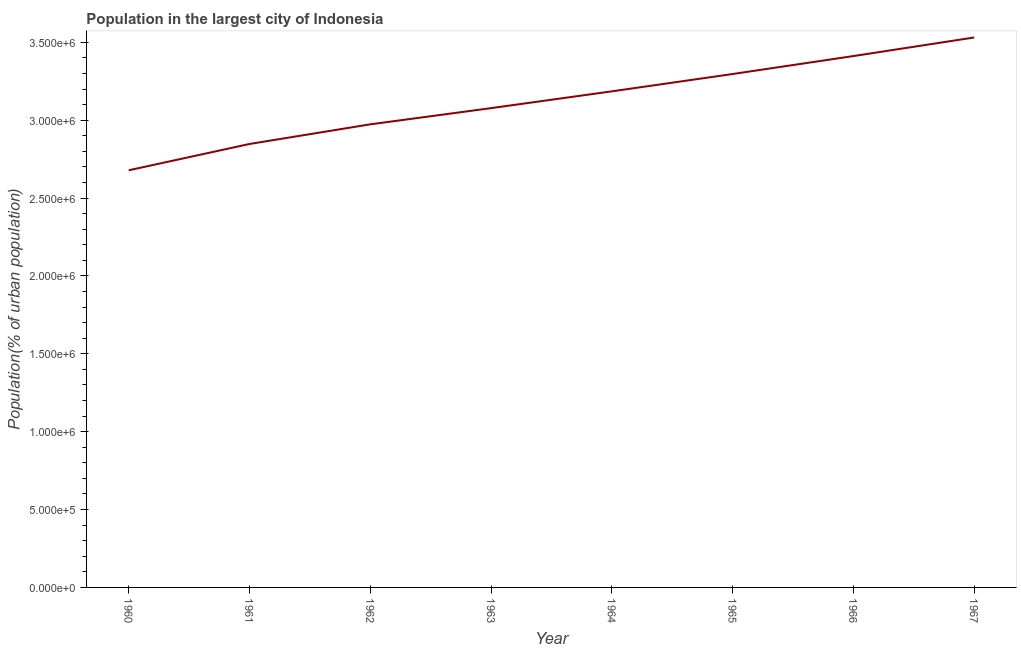What is the population in largest city in 1966?
Ensure brevity in your answer.  3.41e+06. Across all years, what is the maximum population in largest city?
Make the answer very short. 3.53e+06. Across all years, what is the minimum population in largest city?
Make the answer very short. 2.68e+06. In which year was the population in largest city maximum?
Your answer should be very brief. 1967. What is the sum of the population in largest city?
Your response must be concise. 2.50e+07. What is the difference between the population in largest city in 1960 and 1966?
Keep it short and to the point. -7.34e+05. What is the average population in largest city per year?
Your answer should be very brief. 3.13e+06. What is the median population in largest city?
Provide a short and direct response. 3.13e+06. In how many years, is the population in largest city greater than 2100000 %?
Your response must be concise. 8. Do a majority of the years between 1966 and 1960 (inclusive) have population in largest city greater than 500000 %?
Keep it short and to the point. Yes. What is the ratio of the population in largest city in 1965 to that in 1966?
Your answer should be very brief. 0.97. Is the population in largest city in 1963 less than that in 1964?
Your response must be concise. Yes. Is the difference between the population in largest city in 1962 and 1967 greater than the difference between any two years?
Your response must be concise. No. What is the difference between the highest and the second highest population in largest city?
Keep it short and to the point. 1.19e+05. What is the difference between the highest and the lowest population in largest city?
Provide a short and direct response. 8.53e+05. Does the population in largest city monotonically increase over the years?
Make the answer very short. Yes. How many years are there in the graph?
Offer a very short reply. 8. Does the graph contain grids?
Offer a very short reply. No. What is the title of the graph?
Give a very brief answer. Population in the largest city of Indonesia. What is the label or title of the Y-axis?
Make the answer very short. Population(% of urban population). What is the Population(% of urban population) in 1960?
Make the answer very short. 2.68e+06. What is the Population(% of urban population) of 1961?
Give a very brief answer. 2.85e+06. What is the Population(% of urban population) of 1962?
Make the answer very short. 2.97e+06. What is the Population(% of urban population) of 1963?
Provide a short and direct response. 3.08e+06. What is the Population(% of urban population) in 1964?
Keep it short and to the point. 3.19e+06. What is the Population(% of urban population) of 1965?
Provide a short and direct response. 3.30e+06. What is the Population(% of urban population) of 1966?
Your answer should be compact. 3.41e+06. What is the Population(% of urban population) in 1967?
Your response must be concise. 3.53e+06. What is the difference between the Population(% of urban population) in 1960 and 1961?
Offer a terse response. -1.69e+05. What is the difference between the Population(% of urban population) in 1960 and 1962?
Give a very brief answer. -2.95e+05. What is the difference between the Population(% of urban population) in 1960 and 1963?
Offer a terse response. -3.99e+05. What is the difference between the Population(% of urban population) in 1960 and 1964?
Provide a succinct answer. -5.07e+05. What is the difference between the Population(% of urban population) in 1960 and 1965?
Your answer should be compact. -6.18e+05. What is the difference between the Population(% of urban population) in 1960 and 1966?
Your response must be concise. -7.34e+05. What is the difference between the Population(% of urban population) in 1960 and 1967?
Make the answer very short. -8.53e+05. What is the difference between the Population(% of urban population) in 1961 and 1962?
Keep it short and to the point. -1.26e+05. What is the difference between the Population(% of urban population) in 1961 and 1963?
Keep it short and to the point. -2.30e+05. What is the difference between the Population(% of urban population) in 1961 and 1964?
Your answer should be very brief. -3.38e+05. What is the difference between the Population(% of urban population) in 1961 and 1965?
Your response must be concise. -4.49e+05. What is the difference between the Population(% of urban population) in 1961 and 1966?
Ensure brevity in your answer.  -5.65e+05. What is the difference between the Population(% of urban population) in 1961 and 1967?
Make the answer very short. -6.84e+05. What is the difference between the Population(% of urban population) in 1962 and 1963?
Give a very brief answer. -1.04e+05. What is the difference between the Population(% of urban population) in 1962 and 1964?
Give a very brief answer. -2.12e+05. What is the difference between the Population(% of urban population) in 1962 and 1965?
Make the answer very short. -3.23e+05. What is the difference between the Population(% of urban population) in 1962 and 1966?
Make the answer very short. -4.38e+05. What is the difference between the Population(% of urban population) in 1962 and 1967?
Make the answer very short. -5.58e+05. What is the difference between the Population(% of urban population) in 1963 and 1964?
Your response must be concise. -1.08e+05. What is the difference between the Population(% of urban population) in 1963 and 1965?
Offer a terse response. -2.19e+05. What is the difference between the Population(% of urban population) in 1963 and 1966?
Your answer should be very brief. -3.34e+05. What is the difference between the Population(% of urban population) in 1963 and 1967?
Offer a terse response. -4.54e+05. What is the difference between the Population(% of urban population) in 1964 and 1965?
Provide a succinct answer. -1.11e+05. What is the difference between the Population(% of urban population) in 1964 and 1966?
Offer a terse response. -2.27e+05. What is the difference between the Population(% of urban population) in 1964 and 1967?
Provide a succinct answer. -3.46e+05. What is the difference between the Population(% of urban population) in 1965 and 1966?
Keep it short and to the point. -1.15e+05. What is the difference between the Population(% of urban population) in 1965 and 1967?
Ensure brevity in your answer.  -2.35e+05. What is the difference between the Population(% of urban population) in 1966 and 1967?
Your answer should be compact. -1.19e+05. What is the ratio of the Population(% of urban population) in 1960 to that in 1961?
Provide a short and direct response. 0.94. What is the ratio of the Population(% of urban population) in 1960 to that in 1962?
Your response must be concise. 0.9. What is the ratio of the Population(% of urban population) in 1960 to that in 1963?
Give a very brief answer. 0.87. What is the ratio of the Population(% of urban population) in 1960 to that in 1964?
Provide a short and direct response. 0.84. What is the ratio of the Population(% of urban population) in 1960 to that in 1965?
Your response must be concise. 0.81. What is the ratio of the Population(% of urban population) in 1960 to that in 1966?
Your answer should be compact. 0.79. What is the ratio of the Population(% of urban population) in 1960 to that in 1967?
Your response must be concise. 0.76. What is the ratio of the Population(% of urban population) in 1961 to that in 1962?
Your answer should be compact. 0.96. What is the ratio of the Population(% of urban population) in 1961 to that in 1963?
Your response must be concise. 0.93. What is the ratio of the Population(% of urban population) in 1961 to that in 1964?
Your answer should be compact. 0.89. What is the ratio of the Population(% of urban population) in 1961 to that in 1965?
Keep it short and to the point. 0.86. What is the ratio of the Population(% of urban population) in 1961 to that in 1966?
Your answer should be compact. 0.83. What is the ratio of the Population(% of urban population) in 1961 to that in 1967?
Your response must be concise. 0.81. What is the ratio of the Population(% of urban population) in 1962 to that in 1963?
Ensure brevity in your answer.  0.97. What is the ratio of the Population(% of urban population) in 1962 to that in 1964?
Your response must be concise. 0.93. What is the ratio of the Population(% of urban population) in 1962 to that in 1965?
Offer a very short reply. 0.9. What is the ratio of the Population(% of urban population) in 1962 to that in 1966?
Your answer should be compact. 0.87. What is the ratio of the Population(% of urban population) in 1962 to that in 1967?
Give a very brief answer. 0.84. What is the ratio of the Population(% of urban population) in 1963 to that in 1965?
Make the answer very short. 0.93. What is the ratio of the Population(% of urban population) in 1963 to that in 1966?
Ensure brevity in your answer.  0.9. What is the ratio of the Population(% of urban population) in 1963 to that in 1967?
Your answer should be very brief. 0.87. What is the ratio of the Population(% of urban population) in 1964 to that in 1965?
Give a very brief answer. 0.97. What is the ratio of the Population(% of urban population) in 1964 to that in 1966?
Your answer should be very brief. 0.93. What is the ratio of the Population(% of urban population) in 1964 to that in 1967?
Make the answer very short. 0.9. What is the ratio of the Population(% of urban population) in 1965 to that in 1966?
Give a very brief answer. 0.97. What is the ratio of the Population(% of urban population) in 1965 to that in 1967?
Make the answer very short. 0.93. 